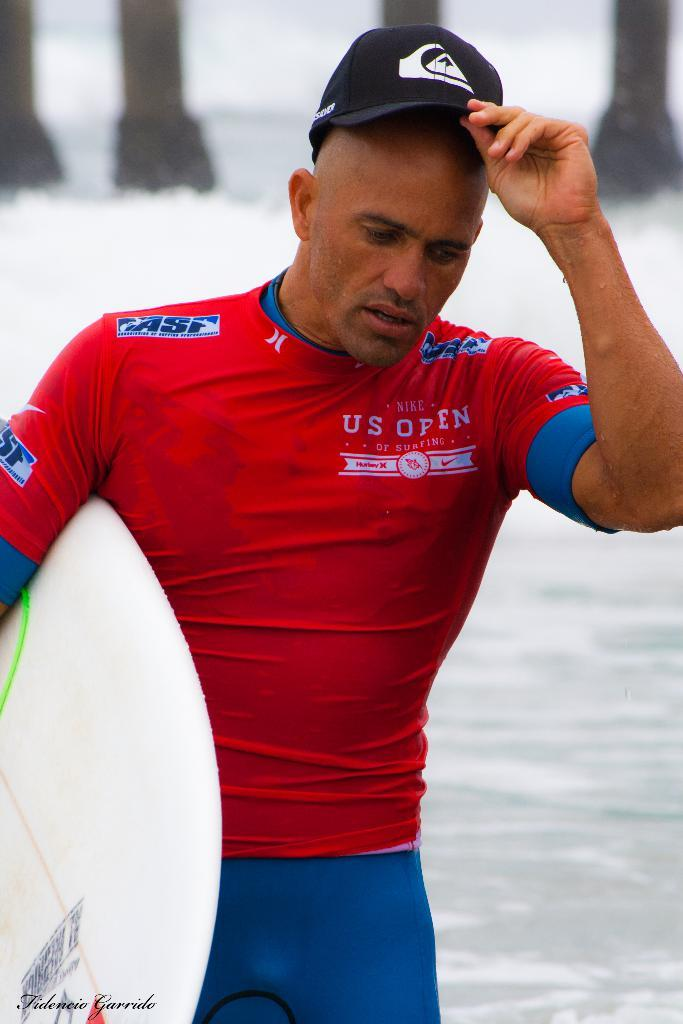<image>
Write a terse but informative summary of the picture. A surfer wearing a red US Open of surfing swimsuit. 